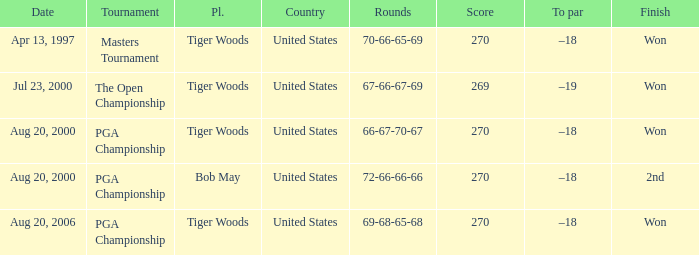What is the worst (highest) score? 270.0. 